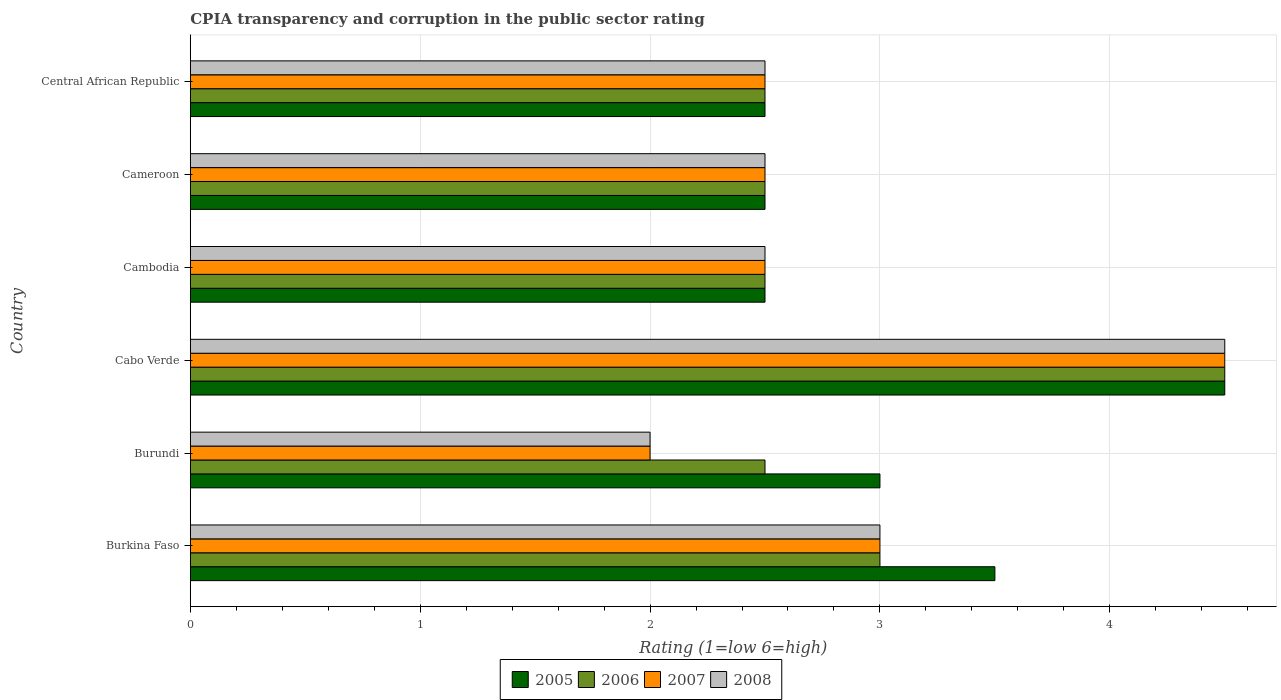How many groups of bars are there?
Offer a very short reply. 6. Are the number of bars per tick equal to the number of legend labels?
Offer a very short reply. Yes. What is the label of the 6th group of bars from the top?
Provide a short and direct response. Burkina Faso. What is the CPIA rating in 2006 in Burundi?
Provide a short and direct response. 2.5. Across all countries, what is the maximum CPIA rating in 2005?
Provide a succinct answer. 4.5. In which country was the CPIA rating in 2007 maximum?
Your answer should be compact. Cabo Verde. In which country was the CPIA rating in 2007 minimum?
Ensure brevity in your answer.  Burundi. What is the total CPIA rating in 2006 in the graph?
Provide a succinct answer. 17.5. What is the average CPIA rating in 2007 per country?
Ensure brevity in your answer.  2.83. What is the ratio of the CPIA rating in 2007 in Burundi to that in Cabo Verde?
Provide a short and direct response. 0.44. Is the CPIA rating in 2008 in Burkina Faso less than that in Central African Republic?
Keep it short and to the point. No. Is the difference between the CPIA rating in 2005 in Burkina Faso and Cabo Verde greater than the difference between the CPIA rating in 2006 in Burkina Faso and Cabo Verde?
Offer a terse response. Yes. In how many countries, is the CPIA rating in 2005 greater than the average CPIA rating in 2005 taken over all countries?
Your answer should be very brief. 2. Is the sum of the CPIA rating in 2006 in Cambodia and Central African Republic greater than the maximum CPIA rating in 2007 across all countries?
Offer a terse response. Yes. Is it the case that in every country, the sum of the CPIA rating in 2006 and CPIA rating in 2005 is greater than the sum of CPIA rating in 2007 and CPIA rating in 2008?
Provide a succinct answer. No. What does the 2nd bar from the top in Cameroon represents?
Your answer should be compact. 2007. What does the 1st bar from the bottom in Burundi represents?
Your answer should be very brief. 2005. Is it the case that in every country, the sum of the CPIA rating in 2007 and CPIA rating in 2008 is greater than the CPIA rating in 2006?
Give a very brief answer. Yes. How many bars are there?
Give a very brief answer. 24. Are all the bars in the graph horizontal?
Ensure brevity in your answer.  Yes. How many countries are there in the graph?
Give a very brief answer. 6. What is the difference between two consecutive major ticks on the X-axis?
Your answer should be very brief. 1. Are the values on the major ticks of X-axis written in scientific E-notation?
Offer a very short reply. No. Does the graph contain any zero values?
Your response must be concise. No. Does the graph contain grids?
Your answer should be very brief. Yes. Where does the legend appear in the graph?
Give a very brief answer. Bottom center. How many legend labels are there?
Give a very brief answer. 4. How are the legend labels stacked?
Offer a terse response. Horizontal. What is the title of the graph?
Provide a succinct answer. CPIA transparency and corruption in the public sector rating. Does "1985" appear as one of the legend labels in the graph?
Provide a succinct answer. No. What is the label or title of the X-axis?
Keep it short and to the point. Rating (1=low 6=high). What is the label or title of the Y-axis?
Provide a short and direct response. Country. What is the Rating (1=low 6=high) in 2005 in Burkina Faso?
Keep it short and to the point. 3.5. What is the Rating (1=low 6=high) of 2006 in Burkina Faso?
Make the answer very short. 3. What is the Rating (1=low 6=high) in 2007 in Burkina Faso?
Offer a terse response. 3. What is the Rating (1=low 6=high) in 2008 in Burkina Faso?
Provide a succinct answer. 3. What is the Rating (1=low 6=high) of 2005 in Burundi?
Ensure brevity in your answer.  3. What is the Rating (1=low 6=high) of 2006 in Burundi?
Make the answer very short. 2.5. What is the Rating (1=low 6=high) in 2007 in Burundi?
Ensure brevity in your answer.  2. What is the Rating (1=low 6=high) of 2005 in Cabo Verde?
Provide a succinct answer. 4.5. What is the Rating (1=low 6=high) of 2006 in Cabo Verde?
Give a very brief answer. 4.5. What is the Rating (1=low 6=high) of 2008 in Cabo Verde?
Your answer should be very brief. 4.5. What is the Rating (1=low 6=high) in 2005 in Cambodia?
Your answer should be compact. 2.5. What is the Rating (1=low 6=high) in 2007 in Cambodia?
Keep it short and to the point. 2.5. What is the Rating (1=low 6=high) of 2007 in Central African Republic?
Your answer should be very brief. 2.5. What is the Rating (1=low 6=high) in 2008 in Central African Republic?
Provide a short and direct response. 2.5. Across all countries, what is the maximum Rating (1=low 6=high) of 2006?
Make the answer very short. 4.5. Across all countries, what is the minimum Rating (1=low 6=high) of 2005?
Ensure brevity in your answer.  2.5. Across all countries, what is the minimum Rating (1=low 6=high) of 2007?
Provide a short and direct response. 2. What is the total Rating (1=low 6=high) of 2007 in the graph?
Keep it short and to the point. 17. What is the difference between the Rating (1=low 6=high) in 2005 in Burkina Faso and that in Burundi?
Ensure brevity in your answer.  0.5. What is the difference between the Rating (1=low 6=high) in 2006 in Burkina Faso and that in Burundi?
Offer a very short reply. 0.5. What is the difference between the Rating (1=low 6=high) in 2008 in Burkina Faso and that in Burundi?
Provide a short and direct response. 1. What is the difference between the Rating (1=low 6=high) in 2005 in Burkina Faso and that in Cambodia?
Keep it short and to the point. 1. What is the difference between the Rating (1=low 6=high) of 2006 in Burkina Faso and that in Cambodia?
Give a very brief answer. 0.5. What is the difference between the Rating (1=low 6=high) in 2005 in Burkina Faso and that in Cameroon?
Keep it short and to the point. 1. What is the difference between the Rating (1=low 6=high) in 2006 in Burkina Faso and that in Cameroon?
Keep it short and to the point. 0.5. What is the difference between the Rating (1=low 6=high) of 2007 in Burkina Faso and that in Cameroon?
Make the answer very short. 0.5. What is the difference between the Rating (1=low 6=high) of 2005 in Burkina Faso and that in Central African Republic?
Ensure brevity in your answer.  1. What is the difference between the Rating (1=low 6=high) in 2008 in Burkina Faso and that in Central African Republic?
Your answer should be compact. 0.5. What is the difference between the Rating (1=low 6=high) of 2007 in Burundi and that in Cabo Verde?
Ensure brevity in your answer.  -2.5. What is the difference between the Rating (1=low 6=high) in 2008 in Burundi and that in Cabo Verde?
Provide a short and direct response. -2.5. What is the difference between the Rating (1=low 6=high) of 2007 in Burundi and that in Cambodia?
Your answer should be very brief. -0.5. What is the difference between the Rating (1=low 6=high) in 2005 in Burundi and that in Cameroon?
Offer a very short reply. 0.5. What is the difference between the Rating (1=low 6=high) of 2006 in Burundi and that in Cameroon?
Offer a very short reply. 0. What is the difference between the Rating (1=low 6=high) in 2005 in Burundi and that in Central African Republic?
Ensure brevity in your answer.  0.5. What is the difference between the Rating (1=low 6=high) of 2006 in Burundi and that in Central African Republic?
Provide a succinct answer. 0. What is the difference between the Rating (1=low 6=high) in 2005 in Cabo Verde and that in Cambodia?
Provide a succinct answer. 2. What is the difference between the Rating (1=low 6=high) in 2007 in Cabo Verde and that in Cambodia?
Make the answer very short. 2. What is the difference between the Rating (1=low 6=high) of 2008 in Cabo Verde and that in Cambodia?
Your answer should be compact. 2. What is the difference between the Rating (1=low 6=high) in 2008 in Cabo Verde and that in Cameroon?
Offer a very short reply. 2. What is the difference between the Rating (1=low 6=high) of 2007 in Cabo Verde and that in Central African Republic?
Provide a succinct answer. 2. What is the difference between the Rating (1=low 6=high) of 2006 in Cambodia and that in Cameroon?
Your response must be concise. 0. What is the difference between the Rating (1=low 6=high) in 2007 in Cambodia and that in Cameroon?
Offer a terse response. 0. What is the difference between the Rating (1=low 6=high) in 2005 in Cambodia and that in Central African Republic?
Give a very brief answer. 0. What is the difference between the Rating (1=low 6=high) of 2008 in Cambodia and that in Central African Republic?
Your response must be concise. 0. What is the difference between the Rating (1=low 6=high) of 2005 in Cameroon and that in Central African Republic?
Provide a succinct answer. 0. What is the difference between the Rating (1=low 6=high) in 2007 in Cameroon and that in Central African Republic?
Offer a terse response. 0. What is the difference between the Rating (1=low 6=high) in 2005 in Burkina Faso and the Rating (1=low 6=high) in 2006 in Burundi?
Make the answer very short. 1. What is the difference between the Rating (1=low 6=high) of 2005 in Burkina Faso and the Rating (1=low 6=high) of 2007 in Burundi?
Your answer should be compact. 1.5. What is the difference between the Rating (1=low 6=high) in 2005 in Burkina Faso and the Rating (1=low 6=high) in 2008 in Burundi?
Your answer should be compact. 1.5. What is the difference between the Rating (1=low 6=high) of 2006 in Burkina Faso and the Rating (1=low 6=high) of 2008 in Burundi?
Your answer should be compact. 1. What is the difference between the Rating (1=low 6=high) of 2007 in Burkina Faso and the Rating (1=low 6=high) of 2008 in Burundi?
Keep it short and to the point. 1. What is the difference between the Rating (1=low 6=high) in 2005 in Burkina Faso and the Rating (1=low 6=high) in 2006 in Cabo Verde?
Provide a short and direct response. -1. What is the difference between the Rating (1=low 6=high) of 2005 in Burkina Faso and the Rating (1=low 6=high) of 2007 in Cabo Verde?
Make the answer very short. -1. What is the difference between the Rating (1=low 6=high) in 2005 in Burkina Faso and the Rating (1=low 6=high) in 2008 in Cabo Verde?
Offer a terse response. -1. What is the difference between the Rating (1=low 6=high) of 2006 in Burkina Faso and the Rating (1=low 6=high) of 2008 in Cabo Verde?
Your response must be concise. -1.5. What is the difference between the Rating (1=low 6=high) of 2007 in Burkina Faso and the Rating (1=low 6=high) of 2008 in Cabo Verde?
Offer a very short reply. -1.5. What is the difference between the Rating (1=low 6=high) of 2005 in Burkina Faso and the Rating (1=low 6=high) of 2006 in Cambodia?
Ensure brevity in your answer.  1. What is the difference between the Rating (1=low 6=high) in 2005 in Burkina Faso and the Rating (1=low 6=high) in 2007 in Cambodia?
Offer a very short reply. 1. What is the difference between the Rating (1=low 6=high) of 2005 in Burkina Faso and the Rating (1=low 6=high) of 2008 in Cambodia?
Ensure brevity in your answer.  1. What is the difference between the Rating (1=low 6=high) of 2006 in Burkina Faso and the Rating (1=low 6=high) of 2007 in Cambodia?
Provide a short and direct response. 0.5. What is the difference between the Rating (1=low 6=high) in 2005 in Burkina Faso and the Rating (1=low 6=high) in 2008 in Cameroon?
Your answer should be very brief. 1. What is the difference between the Rating (1=low 6=high) in 2006 in Burkina Faso and the Rating (1=low 6=high) in 2007 in Cameroon?
Provide a short and direct response. 0.5. What is the difference between the Rating (1=low 6=high) of 2006 in Burkina Faso and the Rating (1=low 6=high) of 2008 in Cameroon?
Give a very brief answer. 0.5. What is the difference between the Rating (1=low 6=high) of 2005 in Burkina Faso and the Rating (1=low 6=high) of 2006 in Central African Republic?
Offer a terse response. 1. What is the difference between the Rating (1=low 6=high) of 2005 in Burkina Faso and the Rating (1=low 6=high) of 2007 in Central African Republic?
Your response must be concise. 1. What is the difference between the Rating (1=low 6=high) in 2005 in Burkina Faso and the Rating (1=low 6=high) in 2008 in Central African Republic?
Your answer should be very brief. 1. What is the difference between the Rating (1=low 6=high) of 2005 in Burundi and the Rating (1=low 6=high) of 2006 in Cabo Verde?
Offer a terse response. -1.5. What is the difference between the Rating (1=low 6=high) of 2005 in Burundi and the Rating (1=low 6=high) of 2007 in Cabo Verde?
Your answer should be very brief. -1.5. What is the difference between the Rating (1=low 6=high) of 2005 in Burundi and the Rating (1=low 6=high) of 2008 in Cabo Verde?
Provide a short and direct response. -1.5. What is the difference between the Rating (1=low 6=high) of 2006 in Burundi and the Rating (1=low 6=high) of 2008 in Cabo Verde?
Your answer should be compact. -2. What is the difference between the Rating (1=low 6=high) in 2007 in Burundi and the Rating (1=low 6=high) in 2008 in Cabo Verde?
Offer a terse response. -2.5. What is the difference between the Rating (1=low 6=high) in 2005 in Burundi and the Rating (1=low 6=high) in 2007 in Cambodia?
Your answer should be compact. 0.5. What is the difference between the Rating (1=low 6=high) in 2005 in Burundi and the Rating (1=low 6=high) in 2008 in Cambodia?
Your response must be concise. 0.5. What is the difference between the Rating (1=low 6=high) of 2005 in Burundi and the Rating (1=low 6=high) of 2006 in Cameroon?
Offer a terse response. 0.5. What is the difference between the Rating (1=low 6=high) in 2006 in Burundi and the Rating (1=low 6=high) in 2008 in Cameroon?
Provide a succinct answer. 0. What is the difference between the Rating (1=low 6=high) of 2007 in Burundi and the Rating (1=low 6=high) of 2008 in Cameroon?
Your answer should be compact. -0.5. What is the difference between the Rating (1=low 6=high) in 2005 in Burundi and the Rating (1=low 6=high) in 2006 in Central African Republic?
Your answer should be very brief. 0.5. What is the difference between the Rating (1=low 6=high) of 2005 in Burundi and the Rating (1=low 6=high) of 2008 in Central African Republic?
Ensure brevity in your answer.  0.5. What is the difference between the Rating (1=low 6=high) in 2006 in Burundi and the Rating (1=low 6=high) in 2007 in Central African Republic?
Give a very brief answer. 0. What is the difference between the Rating (1=low 6=high) of 2007 in Burundi and the Rating (1=low 6=high) of 2008 in Central African Republic?
Offer a very short reply. -0.5. What is the difference between the Rating (1=low 6=high) of 2006 in Cabo Verde and the Rating (1=low 6=high) of 2007 in Cambodia?
Provide a short and direct response. 2. What is the difference between the Rating (1=low 6=high) of 2007 in Cabo Verde and the Rating (1=low 6=high) of 2008 in Cambodia?
Provide a short and direct response. 2. What is the difference between the Rating (1=low 6=high) in 2005 in Cabo Verde and the Rating (1=low 6=high) in 2006 in Cameroon?
Provide a succinct answer. 2. What is the difference between the Rating (1=low 6=high) in 2006 in Cabo Verde and the Rating (1=low 6=high) in 2007 in Cameroon?
Provide a short and direct response. 2. What is the difference between the Rating (1=low 6=high) of 2006 in Cabo Verde and the Rating (1=low 6=high) of 2008 in Cameroon?
Provide a short and direct response. 2. What is the difference between the Rating (1=low 6=high) of 2005 in Cabo Verde and the Rating (1=low 6=high) of 2007 in Central African Republic?
Offer a very short reply. 2. What is the difference between the Rating (1=low 6=high) in 2005 in Cabo Verde and the Rating (1=low 6=high) in 2008 in Central African Republic?
Give a very brief answer. 2. What is the difference between the Rating (1=low 6=high) of 2005 in Cambodia and the Rating (1=low 6=high) of 2008 in Cameroon?
Ensure brevity in your answer.  0. What is the difference between the Rating (1=low 6=high) in 2006 in Cambodia and the Rating (1=low 6=high) in 2008 in Cameroon?
Provide a succinct answer. 0. What is the difference between the Rating (1=low 6=high) in 2005 in Cambodia and the Rating (1=low 6=high) in 2006 in Central African Republic?
Your response must be concise. 0. What is the difference between the Rating (1=low 6=high) in 2005 in Cambodia and the Rating (1=low 6=high) in 2008 in Central African Republic?
Ensure brevity in your answer.  0. What is the difference between the Rating (1=low 6=high) in 2006 in Cambodia and the Rating (1=low 6=high) in 2007 in Central African Republic?
Offer a terse response. 0. What is the difference between the Rating (1=low 6=high) of 2005 in Cameroon and the Rating (1=low 6=high) of 2006 in Central African Republic?
Provide a short and direct response. 0. What is the difference between the Rating (1=low 6=high) in 2005 in Cameroon and the Rating (1=low 6=high) in 2007 in Central African Republic?
Offer a very short reply. 0. What is the difference between the Rating (1=low 6=high) of 2006 in Cameroon and the Rating (1=low 6=high) of 2007 in Central African Republic?
Keep it short and to the point. 0. What is the difference between the Rating (1=low 6=high) in 2007 in Cameroon and the Rating (1=low 6=high) in 2008 in Central African Republic?
Make the answer very short. 0. What is the average Rating (1=low 6=high) of 2005 per country?
Ensure brevity in your answer.  3.08. What is the average Rating (1=low 6=high) of 2006 per country?
Your response must be concise. 2.92. What is the average Rating (1=low 6=high) in 2007 per country?
Make the answer very short. 2.83. What is the average Rating (1=low 6=high) of 2008 per country?
Make the answer very short. 2.83. What is the difference between the Rating (1=low 6=high) of 2005 and Rating (1=low 6=high) of 2006 in Burkina Faso?
Offer a terse response. 0.5. What is the difference between the Rating (1=low 6=high) of 2006 and Rating (1=low 6=high) of 2008 in Burkina Faso?
Offer a terse response. 0. What is the difference between the Rating (1=low 6=high) of 2007 and Rating (1=low 6=high) of 2008 in Burkina Faso?
Provide a short and direct response. 0. What is the difference between the Rating (1=low 6=high) in 2005 and Rating (1=low 6=high) in 2007 in Burundi?
Your answer should be very brief. 1. What is the difference between the Rating (1=low 6=high) of 2006 and Rating (1=low 6=high) of 2008 in Burundi?
Offer a terse response. 0.5. What is the difference between the Rating (1=low 6=high) in 2005 and Rating (1=low 6=high) in 2007 in Cabo Verde?
Offer a terse response. 0. What is the difference between the Rating (1=low 6=high) in 2006 and Rating (1=low 6=high) in 2007 in Cabo Verde?
Ensure brevity in your answer.  0. What is the difference between the Rating (1=low 6=high) of 2006 and Rating (1=low 6=high) of 2008 in Cabo Verde?
Provide a succinct answer. 0. What is the difference between the Rating (1=low 6=high) in 2007 and Rating (1=low 6=high) in 2008 in Cabo Verde?
Your response must be concise. 0. What is the difference between the Rating (1=low 6=high) of 2005 and Rating (1=low 6=high) of 2006 in Cambodia?
Provide a short and direct response. 0. What is the difference between the Rating (1=low 6=high) in 2005 and Rating (1=low 6=high) in 2008 in Cambodia?
Ensure brevity in your answer.  0. What is the difference between the Rating (1=low 6=high) in 2006 and Rating (1=low 6=high) in 2007 in Cambodia?
Your answer should be compact. 0. What is the difference between the Rating (1=low 6=high) of 2007 and Rating (1=low 6=high) of 2008 in Cambodia?
Make the answer very short. 0. What is the difference between the Rating (1=low 6=high) of 2005 and Rating (1=low 6=high) of 2006 in Cameroon?
Your response must be concise. 0. What is the difference between the Rating (1=low 6=high) of 2005 and Rating (1=low 6=high) of 2007 in Cameroon?
Your answer should be very brief. 0. What is the difference between the Rating (1=low 6=high) in 2005 and Rating (1=low 6=high) in 2006 in Central African Republic?
Provide a succinct answer. 0. What is the difference between the Rating (1=low 6=high) of 2005 and Rating (1=low 6=high) of 2008 in Central African Republic?
Your response must be concise. 0. What is the difference between the Rating (1=low 6=high) in 2006 and Rating (1=low 6=high) in 2007 in Central African Republic?
Your response must be concise. 0. What is the difference between the Rating (1=low 6=high) of 2006 and Rating (1=low 6=high) of 2008 in Central African Republic?
Your response must be concise. 0. What is the ratio of the Rating (1=low 6=high) in 2005 in Burkina Faso to that in Burundi?
Your answer should be compact. 1.17. What is the ratio of the Rating (1=low 6=high) in 2006 in Burkina Faso to that in Burundi?
Provide a short and direct response. 1.2. What is the ratio of the Rating (1=low 6=high) in 2007 in Burkina Faso to that in Burundi?
Provide a succinct answer. 1.5. What is the ratio of the Rating (1=low 6=high) in 2008 in Burkina Faso to that in Burundi?
Your answer should be compact. 1.5. What is the ratio of the Rating (1=low 6=high) of 2005 in Burkina Faso to that in Cabo Verde?
Provide a succinct answer. 0.78. What is the ratio of the Rating (1=low 6=high) of 2007 in Burkina Faso to that in Cabo Verde?
Ensure brevity in your answer.  0.67. What is the ratio of the Rating (1=low 6=high) of 2008 in Burkina Faso to that in Cabo Verde?
Keep it short and to the point. 0.67. What is the ratio of the Rating (1=low 6=high) in 2005 in Burkina Faso to that in Cambodia?
Ensure brevity in your answer.  1.4. What is the ratio of the Rating (1=low 6=high) in 2007 in Burkina Faso to that in Cambodia?
Provide a succinct answer. 1.2. What is the ratio of the Rating (1=low 6=high) in 2008 in Burkina Faso to that in Cambodia?
Offer a terse response. 1.2. What is the ratio of the Rating (1=low 6=high) in 2006 in Burkina Faso to that in Cameroon?
Your answer should be very brief. 1.2. What is the ratio of the Rating (1=low 6=high) in 2005 in Burkina Faso to that in Central African Republic?
Your response must be concise. 1.4. What is the ratio of the Rating (1=low 6=high) in 2007 in Burkina Faso to that in Central African Republic?
Offer a very short reply. 1.2. What is the ratio of the Rating (1=low 6=high) in 2005 in Burundi to that in Cabo Verde?
Give a very brief answer. 0.67. What is the ratio of the Rating (1=low 6=high) in 2006 in Burundi to that in Cabo Verde?
Provide a short and direct response. 0.56. What is the ratio of the Rating (1=low 6=high) of 2007 in Burundi to that in Cabo Verde?
Your answer should be compact. 0.44. What is the ratio of the Rating (1=low 6=high) in 2008 in Burundi to that in Cabo Verde?
Provide a succinct answer. 0.44. What is the ratio of the Rating (1=low 6=high) in 2005 in Burundi to that in Cambodia?
Your answer should be very brief. 1.2. What is the ratio of the Rating (1=low 6=high) in 2006 in Burundi to that in Cambodia?
Your answer should be compact. 1. What is the ratio of the Rating (1=low 6=high) of 2008 in Burundi to that in Cambodia?
Make the answer very short. 0.8. What is the ratio of the Rating (1=low 6=high) of 2006 in Burundi to that in Cameroon?
Give a very brief answer. 1. What is the ratio of the Rating (1=low 6=high) in 2007 in Burundi to that in Cameroon?
Your response must be concise. 0.8. What is the ratio of the Rating (1=low 6=high) of 2005 in Burundi to that in Central African Republic?
Your answer should be compact. 1.2. What is the ratio of the Rating (1=low 6=high) in 2006 in Burundi to that in Central African Republic?
Give a very brief answer. 1. What is the ratio of the Rating (1=low 6=high) of 2006 in Cabo Verde to that in Cambodia?
Provide a short and direct response. 1.8. What is the ratio of the Rating (1=low 6=high) in 2007 in Cabo Verde to that in Cambodia?
Your response must be concise. 1.8. What is the ratio of the Rating (1=low 6=high) of 2008 in Cabo Verde to that in Cambodia?
Make the answer very short. 1.8. What is the ratio of the Rating (1=low 6=high) of 2005 in Cabo Verde to that in Cameroon?
Ensure brevity in your answer.  1.8. What is the ratio of the Rating (1=low 6=high) in 2006 in Cabo Verde to that in Cameroon?
Your answer should be very brief. 1.8. What is the ratio of the Rating (1=low 6=high) of 2007 in Cabo Verde to that in Central African Republic?
Offer a very short reply. 1.8. What is the ratio of the Rating (1=low 6=high) in 2005 in Cambodia to that in Cameroon?
Give a very brief answer. 1. What is the ratio of the Rating (1=low 6=high) in 2008 in Cambodia to that in Cameroon?
Ensure brevity in your answer.  1. What is the ratio of the Rating (1=low 6=high) in 2007 in Cambodia to that in Central African Republic?
Your answer should be compact. 1. What is the ratio of the Rating (1=low 6=high) in 2005 in Cameroon to that in Central African Republic?
Your response must be concise. 1. What is the ratio of the Rating (1=low 6=high) in 2006 in Cameroon to that in Central African Republic?
Provide a short and direct response. 1. What is the ratio of the Rating (1=low 6=high) of 2007 in Cameroon to that in Central African Republic?
Your response must be concise. 1. What is the difference between the highest and the second highest Rating (1=low 6=high) of 2005?
Your answer should be very brief. 1. What is the difference between the highest and the second highest Rating (1=low 6=high) in 2007?
Your answer should be compact. 1.5. 